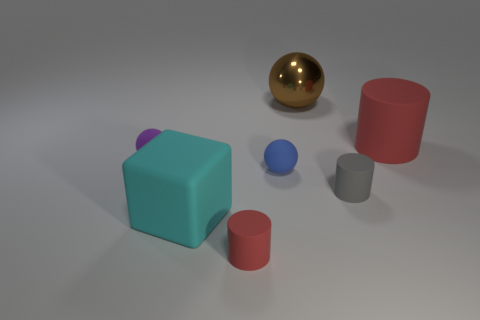What colors are the objects in the image? In the image, there are objects in blue, pink, red, gold, and grey colors. Which object seems out of place based on its material? The gold sphere stands out due to its shiny metallic surface, which contrasts with the other objects that have matte finishes. 